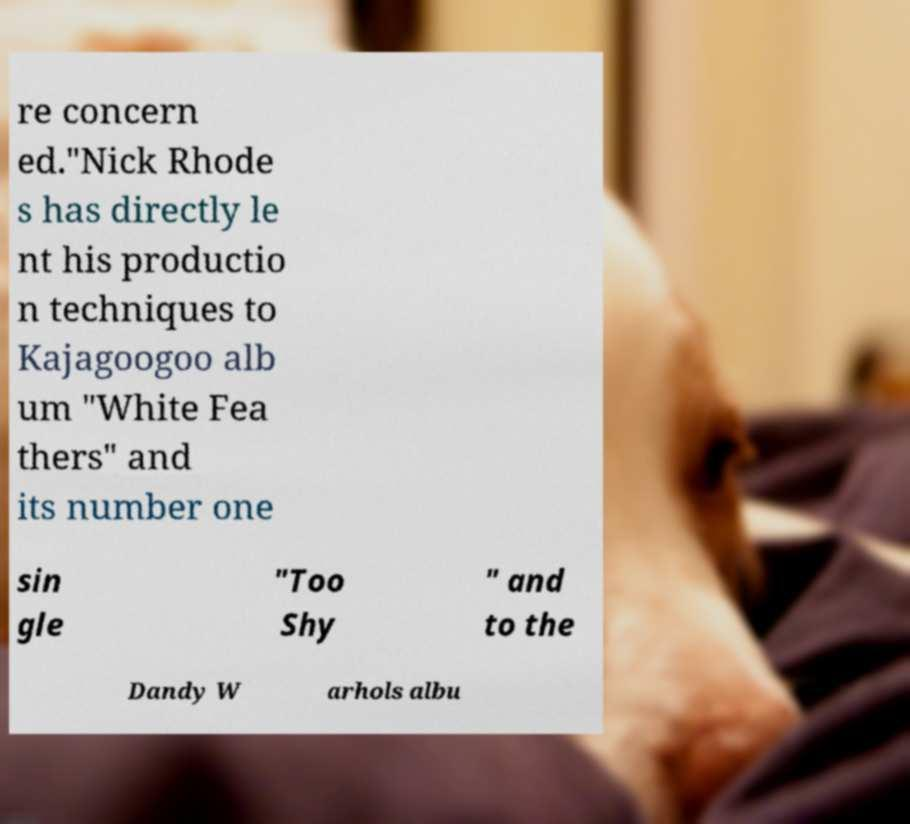I need the written content from this picture converted into text. Can you do that? re concern ed."Nick Rhode s has directly le nt his productio n techniques to Kajagoogoo alb um "White Fea thers" and its number one sin gle "Too Shy " and to the Dandy W arhols albu 